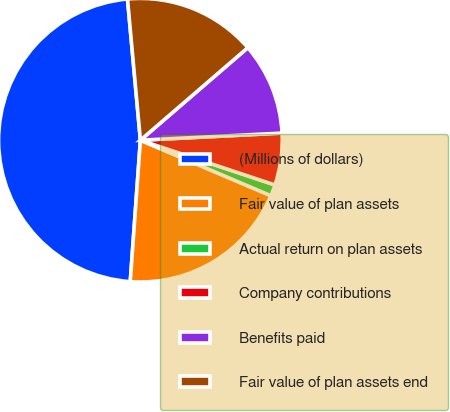Convert chart to OTSL. <chart><loc_0><loc_0><loc_500><loc_500><pie_chart><fcel>(Millions of dollars)<fcel>Fair value of plan assets<fcel>Actual return on plan assets<fcel>Company contributions<fcel>Benefits paid<fcel>Fair value of plan assets end<nl><fcel>47.41%<fcel>19.74%<fcel>1.29%<fcel>5.91%<fcel>10.52%<fcel>15.13%<nl></chart> 